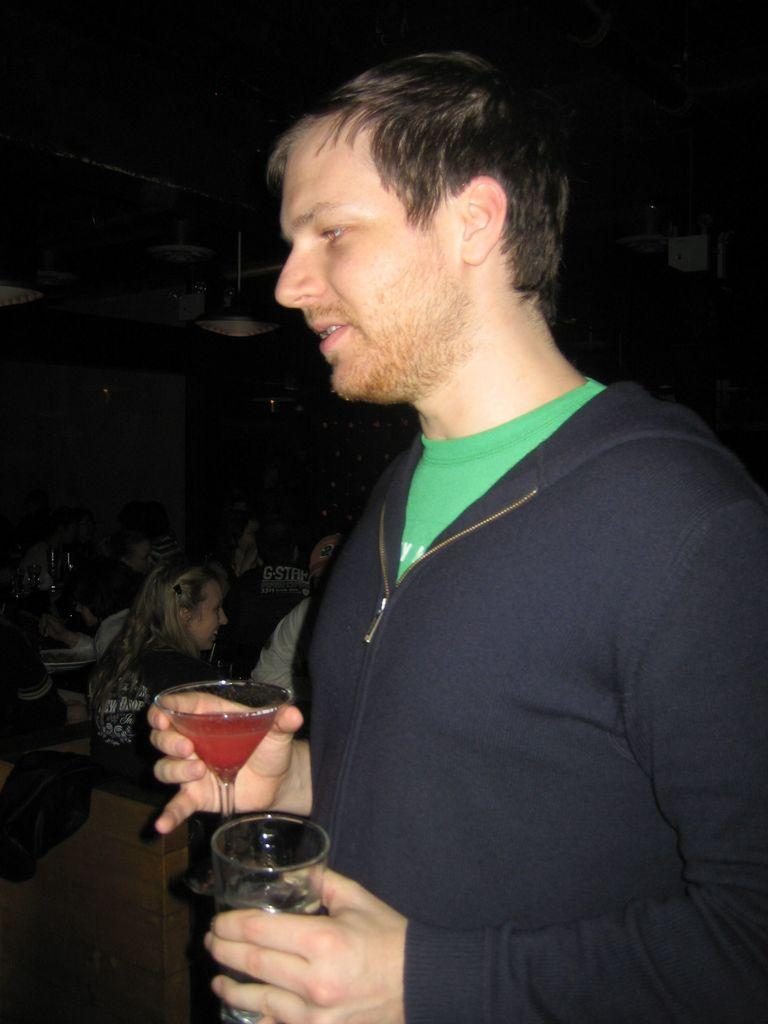What is the man in the image doing? The man is standing in the image and holding glasses. Can you describe the people in the image besides the man? There is a group of people sitting in the image. What can be seen in the background of the image? There are objects visible in the background of the image. What time of day is it in the image, and is there a window visible? The time of day cannot be determined from the image, and there is no window visible. 